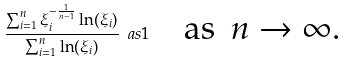Convert formula to latex. <formula><loc_0><loc_0><loc_500><loc_500>\frac { \sum _ { i = 1 } ^ { n } \xi _ { i } ^ { - \frac { 1 } { n - 1 } } \ln ( \xi _ { i } ) } { \sum _ { i = 1 } ^ { n } \ln ( \xi _ { i } ) } \ a s 1 \quad \text {as \ $n\to\infty$.}</formula> 